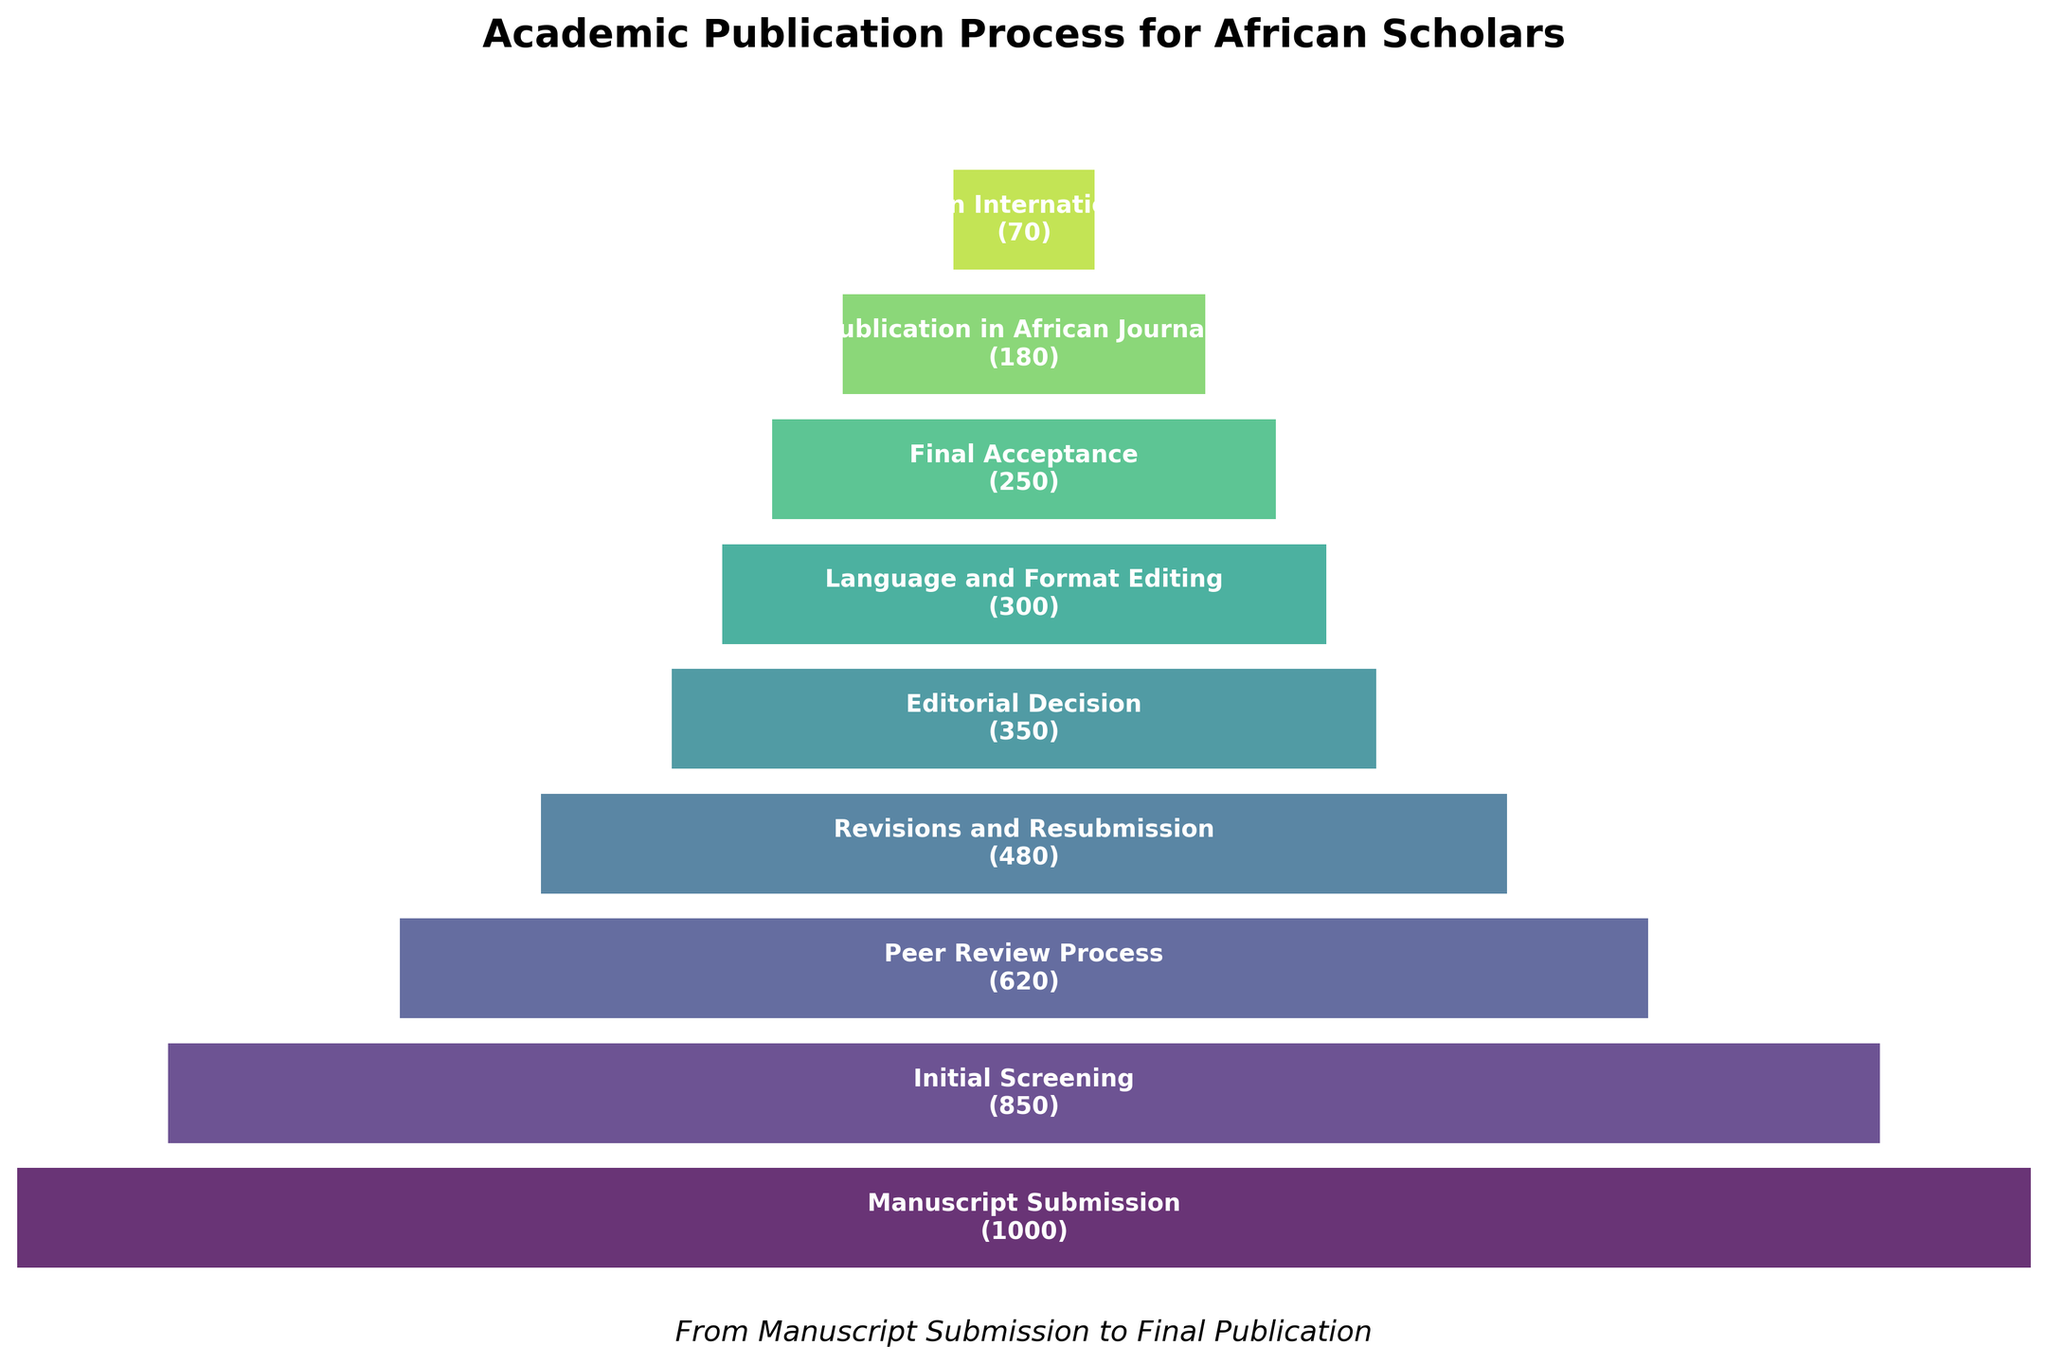What is the title of the funnel chart? The title appears at the top of the chart and usually summarizes the content. Here, it states the main topic of the chart.
Answer: Academic Publication Process for African Scholars How many scholars were left after the Peer Review Process stage? To find this, locate the Peer Review Process stage on the chart and check the corresponding number of scholars next to it.
Answer: 620 At which stages do the number of scholars halve compared to the previous stage? Compare the number of scholars at each stage sequentially and identify where the number roughly halves. For example, from Initial Screening to Peer Review Process, check if 620 is about half of 850, etc.
Answer: Revisions and Resubmission (480 from 850), Publication in International Journals (70 from 180) Which stage shows the largest drop in the number of scholars from the previous stage? Calculate the differences between consecutive stages and identify the largest drop. For instance, compare 1,000 - 850, 850 - 620, etc.
Answer: Initial Screening to Peer Review Process (850 - 620 = 230) Based on the chart, which publication type (African Journals or International Journals) accepts fewer scholars? Compare the numbers at the final two stages: Publication in African Journals and Publication in International Journals.
Answer: International Journals (70 vs 180) How many scholars went through the Initial Screening stage compared to those who made it to the Editorial Decision stage? Identify the number of scholars at each stage and compare the two. Initial Screening has 850 and Editorial Decision has 350.
Answer: 850 vs. 350 Which stage comes right before the Final Acceptance stage, and how many scholars are there at that stage? Check the stage listed immediately before Final Acceptance and note the number of scholars at that stage.
Answer: Language and Format Editing, 300 